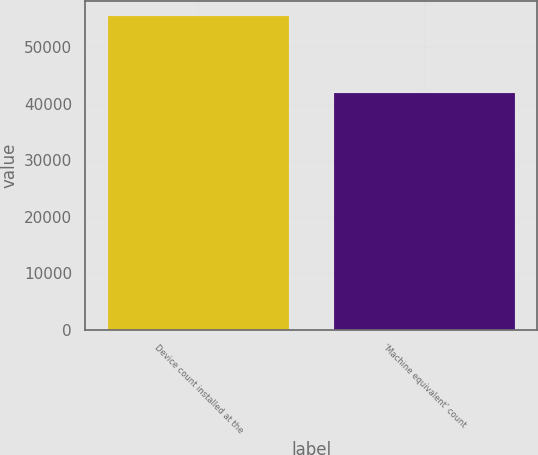Convert chart to OTSL. <chart><loc_0><loc_0><loc_500><loc_500><bar_chart><fcel>Device count installed at the<fcel>'Machine equivalent' count<nl><fcel>55510<fcel>41905<nl></chart> 